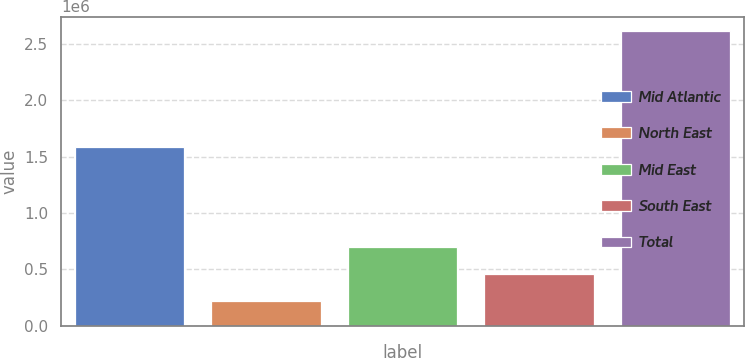<chart> <loc_0><loc_0><loc_500><loc_500><bar_chart><fcel>Mid Atlantic<fcel>North East<fcel>Mid East<fcel>South East<fcel>Total<nl><fcel>1.58283e+06<fcel>221146<fcel>699156<fcel>460151<fcel>2.6112e+06<nl></chart> 